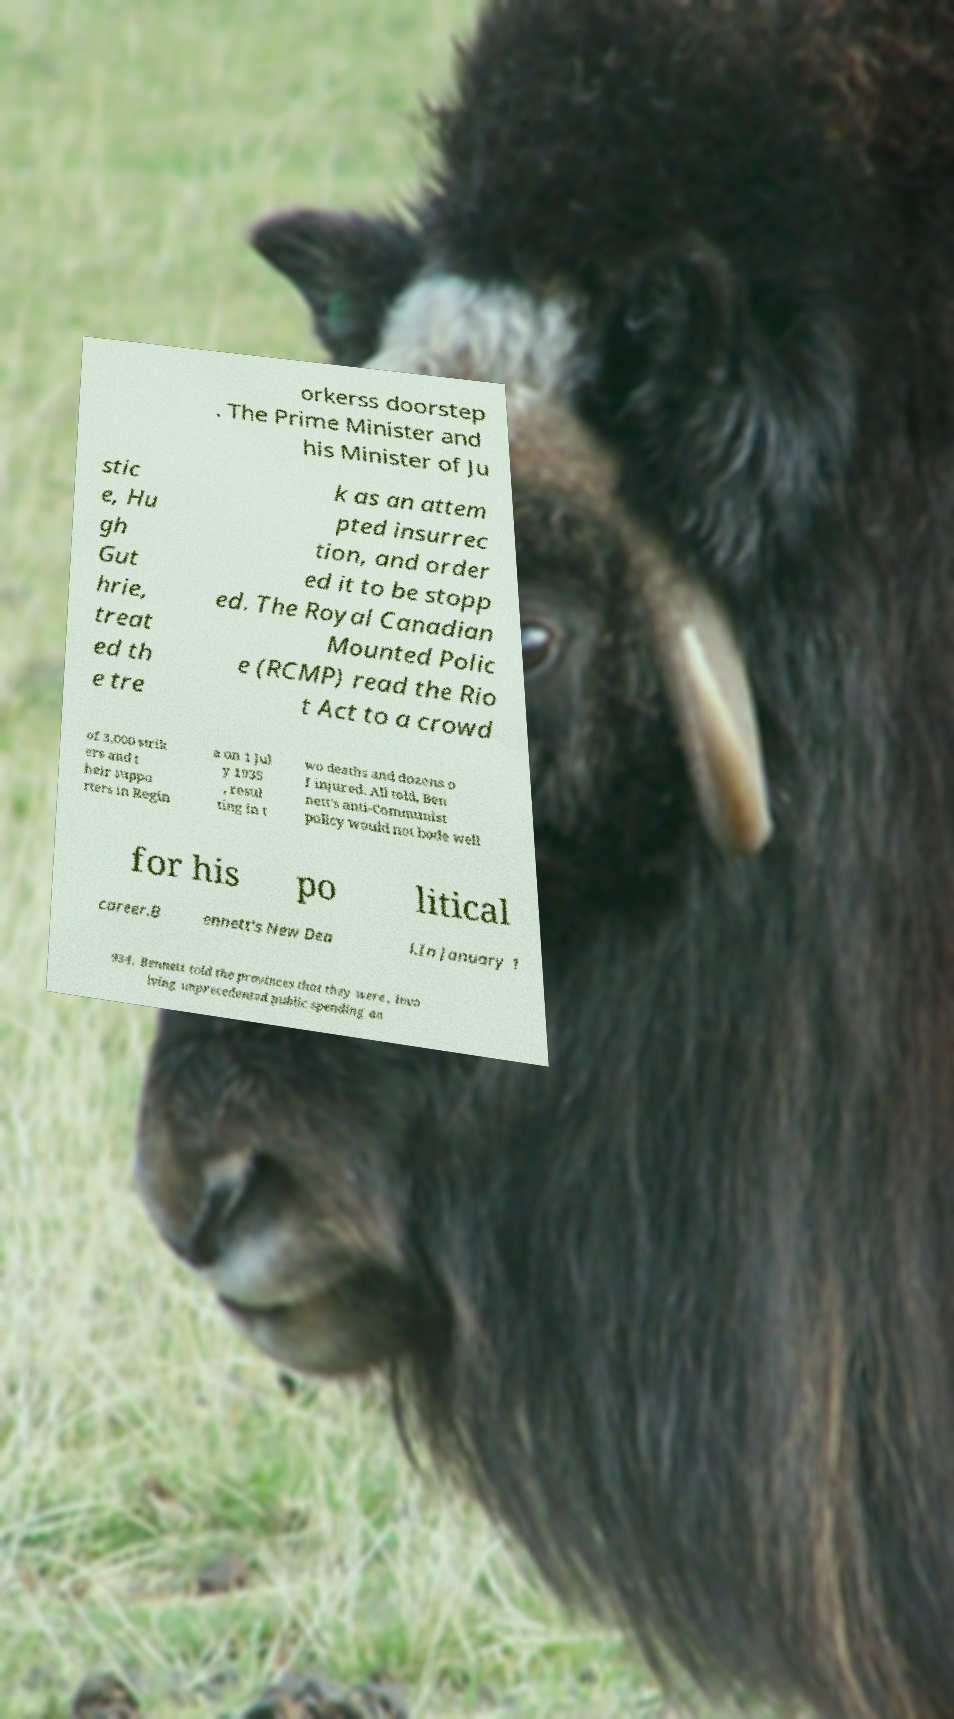What messages or text are displayed in this image? I need them in a readable, typed format. orkerss doorstep . The Prime Minister and his Minister of Ju stic e, Hu gh Gut hrie, treat ed th e tre k as an attem pted insurrec tion, and order ed it to be stopp ed. The Royal Canadian Mounted Polic e (RCMP) read the Rio t Act to a crowd of 3,000 strik ers and t heir suppo rters in Regin a on 1 Jul y 1935 , resul ting in t wo deaths and dozens o f injured. All told, Ben nett's anti-Communist policy would not bode well for his po litical career.B ennett's New Dea l.In January 1 934, Bennett told the provinces that they were , invo lving unprecedented public spending an 